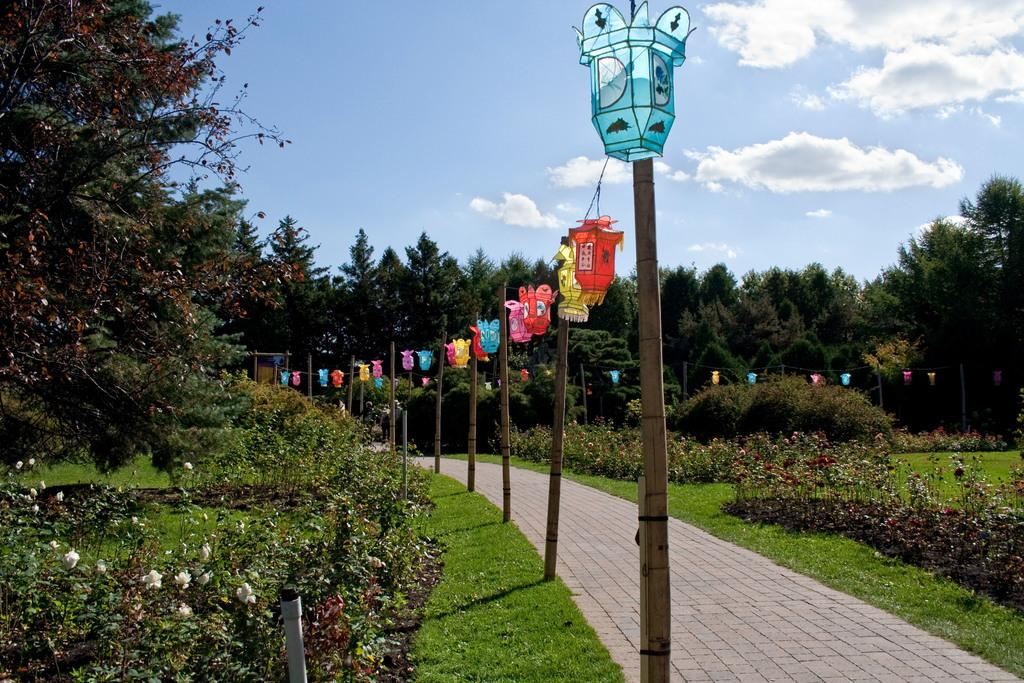What type of plants can be seen in the image? There are plants with flowers in the image. What type of vegetation is present on the ground? There is grass in the image. What structures can be seen in the image? There are poles and trees in the image. What type of path is visible in the image? There is a walkway in the image. What decorative items are present in the image? There are paper lanterns with ropes in the image. What part of the natural environment is visible in the image? The sky is visible in the image. Can you tell me where the toothbrush is located in the image? There is no toothbrush present in the image. How many firemen are visible in the image? There are no firemen present in the image. 